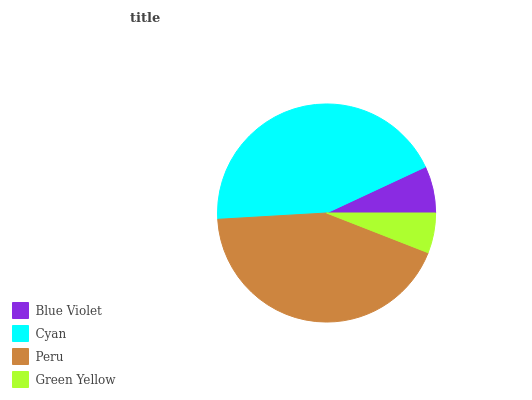Is Green Yellow the minimum?
Answer yes or no. Yes. Is Cyan the maximum?
Answer yes or no. Yes. Is Peru the minimum?
Answer yes or no. No. Is Peru the maximum?
Answer yes or no. No. Is Cyan greater than Peru?
Answer yes or no. Yes. Is Peru less than Cyan?
Answer yes or no. Yes. Is Peru greater than Cyan?
Answer yes or no. No. Is Cyan less than Peru?
Answer yes or no. No. Is Peru the high median?
Answer yes or no. Yes. Is Blue Violet the low median?
Answer yes or no. Yes. Is Cyan the high median?
Answer yes or no. No. Is Cyan the low median?
Answer yes or no. No. 